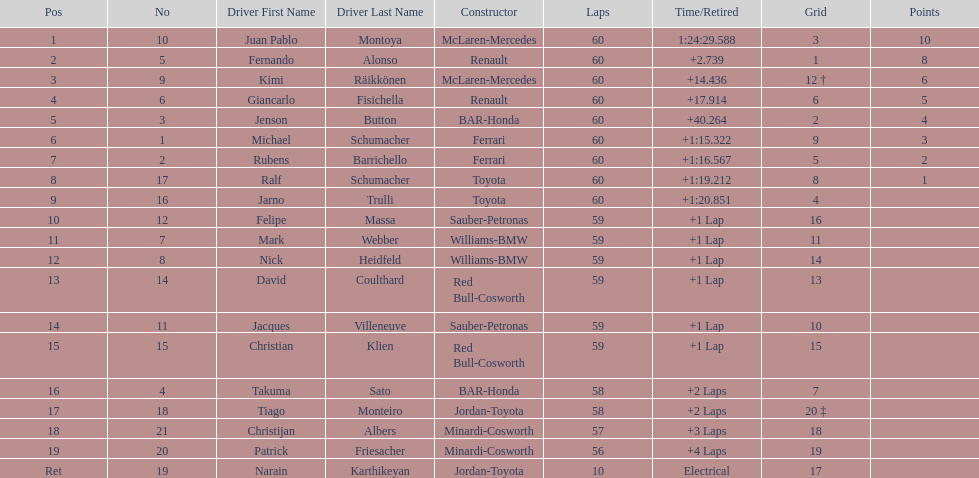Which driver has his grid at 2? Jenson Button. 